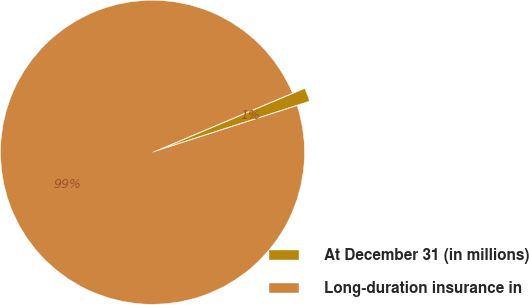Convert chart to OTSL. <chart><loc_0><loc_0><loc_500><loc_500><pie_chart><fcel>At December 31 (in millions)<fcel>Long-duration insurance in<nl><fcel>1.41%<fcel>98.59%<nl></chart> 